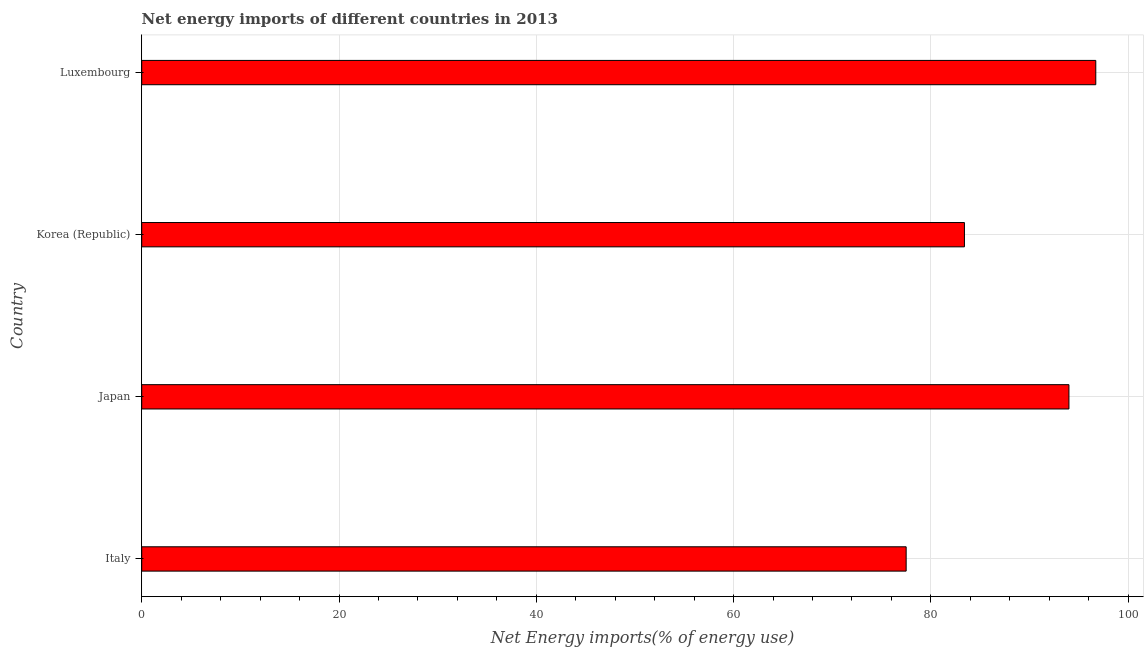Does the graph contain grids?
Ensure brevity in your answer.  Yes. What is the title of the graph?
Your answer should be compact. Net energy imports of different countries in 2013. What is the label or title of the X-axis?
Offer a very short reply. Net Energy imports(% of energy use). What is the energy imports in Italy?
Give a very brief answer. 77.5. Across all countries, what is the maximum energy imports?
Offer a very short reply. 96.72. Across all countries, what is the minimum energy imports?
Your response must be concise. 77.5. In which country was the energy imports maximum?
Provide a succinct answer. Luxembourg. What is the sum of the energy imports?
Offer a terse response. 351.62. What is the difference between the energy imports in Italy and Luxembourg?
Provide a succinct answer. -19.22. What is the average energy imports per country?
Offer a terse response. 87.91. What is the median energy imports?
Provide a succinct answer. 88.7. In how many countries, is the energy imports greater than 12 %?
Make the answer very short. 4. What is the ratio of the energy imports in Italy to that in Japan?
Provide a short and direct response. 0.82. Is the energy imports in Italy less than that in Luxembourg?
Offer a terse response. Yes. What is the difference between the highest and the second highest energy imports?
Provide a short and direct response. 2.72. Is the sum of the energy imports in Korea (Republic) and Luxembourg greater than the maximum energy imports across all countries?
Make the answer very short. Yes. What is the difference between the highest and the lowest energy imports?
Give a very brief answer. 19.22. In how many countries, is the energy imports greater than the average energy imports taken over all countries?
Your answer should be very brief. 2. How many bars are there?
Keep it short and to the point. 4. Are the values on the major ticks of X-axis written in scientific E-notation?
Ensure brevity in your answer.  No. What is the Net Energy imports(% of energy use) in Italy?
Offer a terse response. 77.5. What is the Net Energy imports(% of energy use) of Japan?
Your answer should be very brief. 94. What is the Net Energy imports(% of energy use) of Korea (Republic)?
Give a very brief answer. 83.4. What is the Net Energy imports(% of energy use) of Luxembourg?
Offer a terse response. 96.72. What is the difference between the Net Energy imports(% of energy use) in Italy and Japan?
Your response must be concise. -16.5. What is the difference between the Net Energy imports(% of energy use) in Italy and Korea (Republic)?
Ensure brevity in your answer.  -5.91. What is the difference between the Net Energy imports(% of energy use) in Italy and Luxembourg?
Ensure brevity in your answer.  -19.22. What is the difference between the Net Energy imports(% of energy use) in Japan and Korea (Republic)?
Make the answer very short. 10.59. What is the difference between the Net Energy imports(% of energy use) in Japan and Luxembourg?
Provide a succinct answer. -2.72. What is the difference between the Net Energy imports(% of energy use) in Korea (Republic) and Luxembourg?
Give a very brief answer. -13.32. What is the ratio of the Net Energy imports(% of energy use) in Italy to that in Japan?
Offer a very short reply. 0.82. What is the ratio of the Net Energy imports(% of energy use) in Italy to that in Korea (Republic)?
Give a very brief answer. 0.93. What is the ratio of the Net Energy imports(% of energy use) in Italy to that in Luxembourg?
Your answer should be very brief. 0.8. What is the ratio of the Net Energy imports(% of energy use) in Japan to that in Korea (Republic)?
Your response must be concise. 1.13. What is the ratio of the Net Energy imports(% of energy use) in Korea (Republic) to that in Luxembourg?
Offer a very short reply. 0.86. 